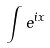<formula> <loc_0><loc_0><loc_500><loc_500>\int e ^ { i x }</formula> 